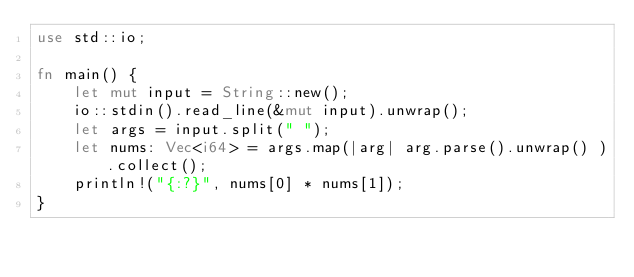<code> <loc_0><loc_0><loc_500><loc_500><_Rust_>use std::io;

fn main() {
    let mut input = String::new();
    io::stdin().read_line(&mut input).unwrap();
    let args = input.split(" ");
    let nums: Vec<i64> = args.map(|arg| arg.parse().unwrap() ).collect();
    println!("{:?}", nums[0] * nums[1]);
}
</code> 